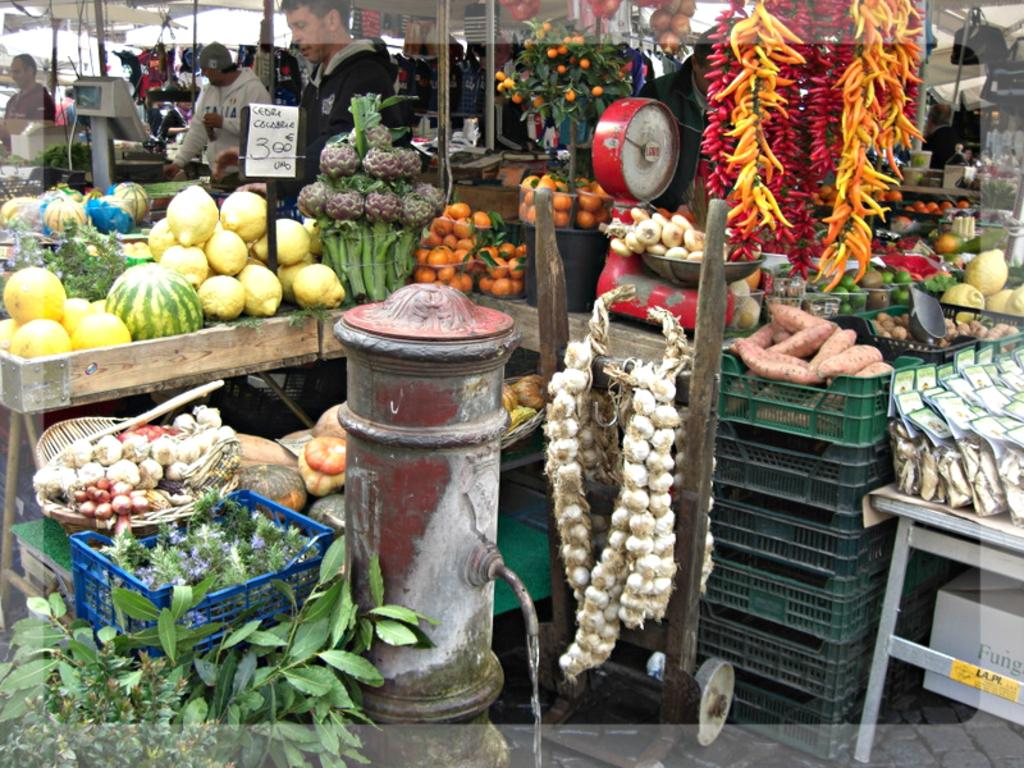What type of market is depicted in the image? The image depicts a vegetable market. What types of items can be seen in the image? There are vegetables, fruits, price tags, a weighing machine, a hydrant, baskets, people, and rods visible in the image. How are the prices of the items displayed in the image? Price tags are visible in the image. What tool is used to weigh the items in the image? A weighing machine is present in the image. What type of grain is being sold in the image? There is no grain visible in the image; it depicts a vegetable market with fruits and vegetables. How comfortable are the chairs in the image? There are no chairs present in the image, as it depicts a vegetable market with various items and objects related to the market. 